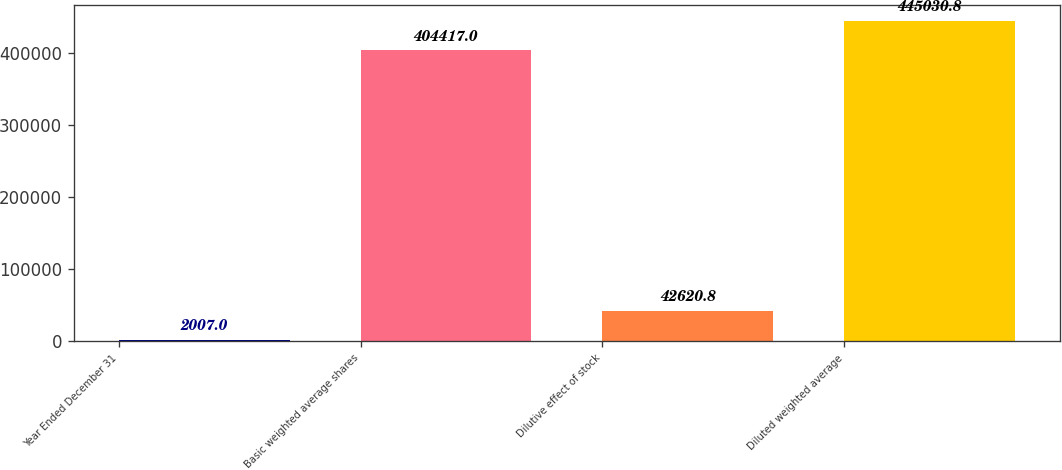Convert chart. <chart><loc_0><loc_0><loc_500><loc_500><bar_chart><fcel>Year Ended December 31<fcel>Basic weighted average shares<fcel>Dilutive effect of stock<fcel>Diluted weighted average<nl><fcel>2007<fcel>404417<fcel>42620.8<fcel>445031<nl></chart> 